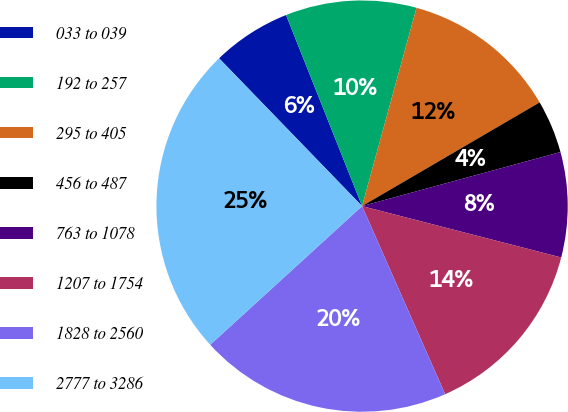Convert chart. <chart><loc_0><loc_0><loc_500><loc_500><pie_chart><fcel>033 to 039<fcel>192 to 257<fcel>295 to 405<fcel>456 to 487<fcel>763 to 1078<fcel>1207 to 1754<fcel>1828 to 2560<fcel>2777 to 3286<nl><fcel>6.21%<fcel>10.29%<fcel>12.32%<fcel>4.18%<fcel>8.25%<fcel>14.36%<fcel>19.84%<fcel>24.54%<nl></chart> 